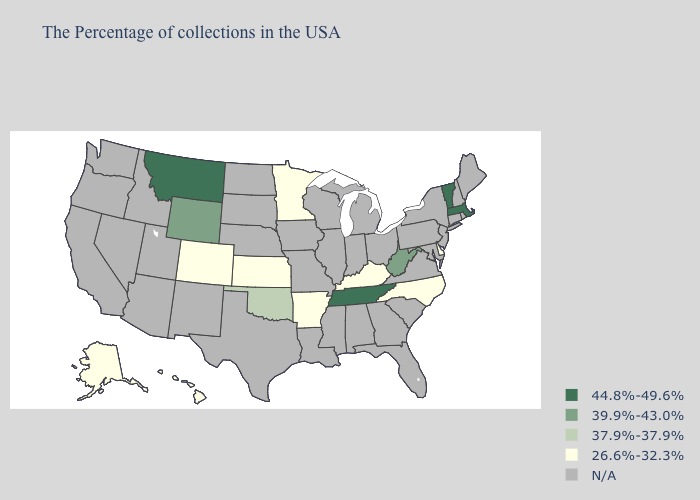What is the lowest value in the USA?
Short answer required. 26.6%-32.3%. What is the highest value in the South ?
Keep it brief. 44.8%-49.6%. Which states have the highest value in the USA?
Be succinct. Massachusetts, Vermont, Tennessee, Montana. Does Oklahoma have the lowest value in the USA?
Be succinct. No. Is the legend a continuous bar?
Short answer required. No. What is the value of Rhode Island?
Be succinct. N/A. Among the states that border New Jersey , which have the lowest value?
Keep it brief. Delaware. Name the states that have a value in the range 39.9%-43.0%?
Keep it brief. West Virginia, Wyoming. What is the value of Mississippi?
Give a very brief answer. N/A. Name the states that have a value in the range 37.9%-37.9%?
Short answer required. Oklahoma. How many symbols are there in the legend?
Be succinct. 5. Does Montana have the lowest value in the USA?
Quick response, please. No. 